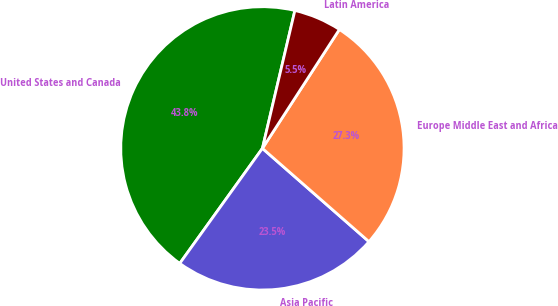Convert chart to OTSL. <chart><loc_0><loc_0><loc_500><loc_500><pie_chart><fcel>United States and Canada<fcel>Asia Pacific<fcel>Europe Middle East and Africa<fcel>Latin America<nl><fcel>43.76%<fcel>23.47%<fcel>27.3%<fcel>5.46%<nl></chart> 